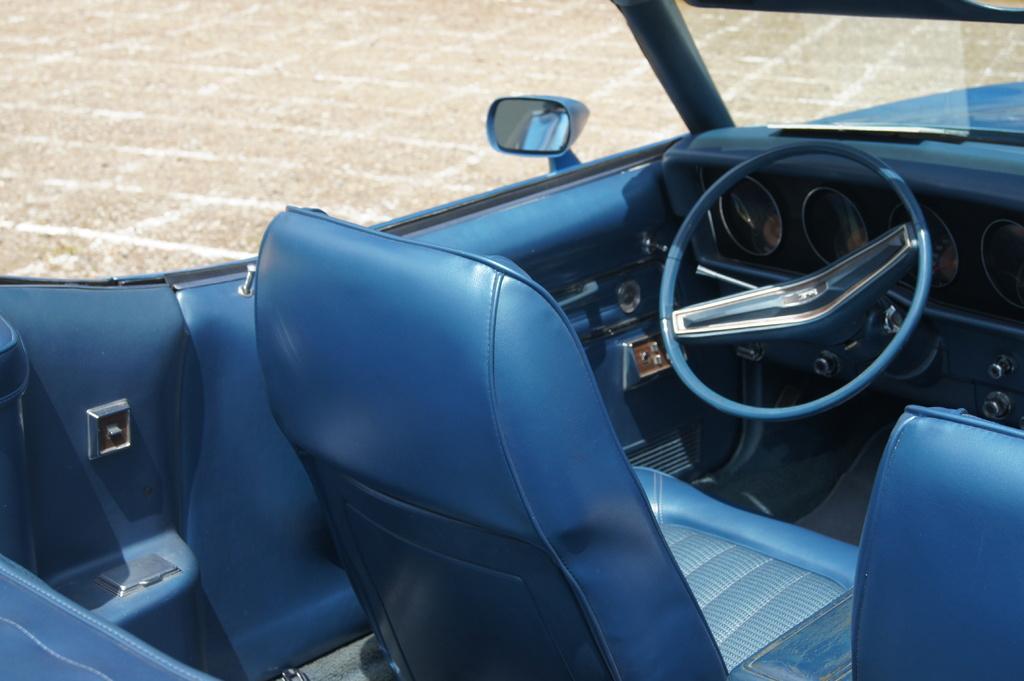Can you describe this image briefly? In this image we can see seats, steering in the car. In the background there is ground. 